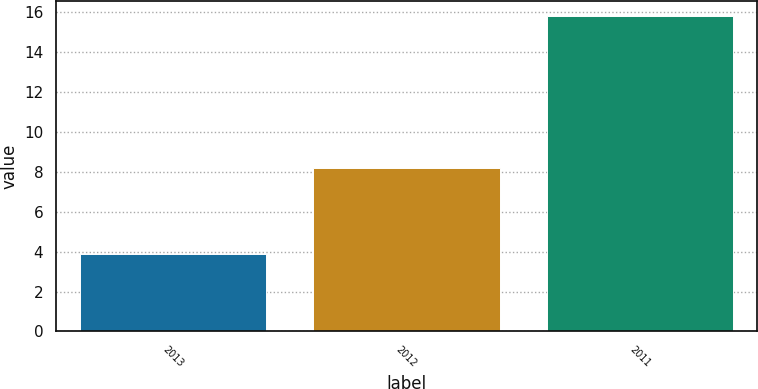Convert chart to OTSL. <chart><loc_0><loc_0><loc_500><loc_500><bar_chart><fcel>2013<fcel>2012<fcel>2011<nl><fcel>3.9<fcel>8.2<fcel>15.8<nl></chart> 